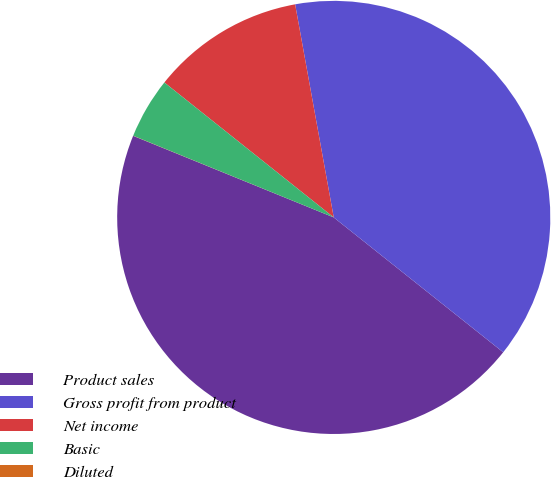Convert chart. <chart><loc_0><loc_0><loc_500><loc_500><pie_chart><fcel>Product sales<fcel>Gross profit from product<fcel>Net income<fcel>Basic<fcel>Diluted<nl><fcel>45.45%<fcel>38.55%<fcel>11.44%<fcel>4.55%<fcel>0.01%<nl></chart> 